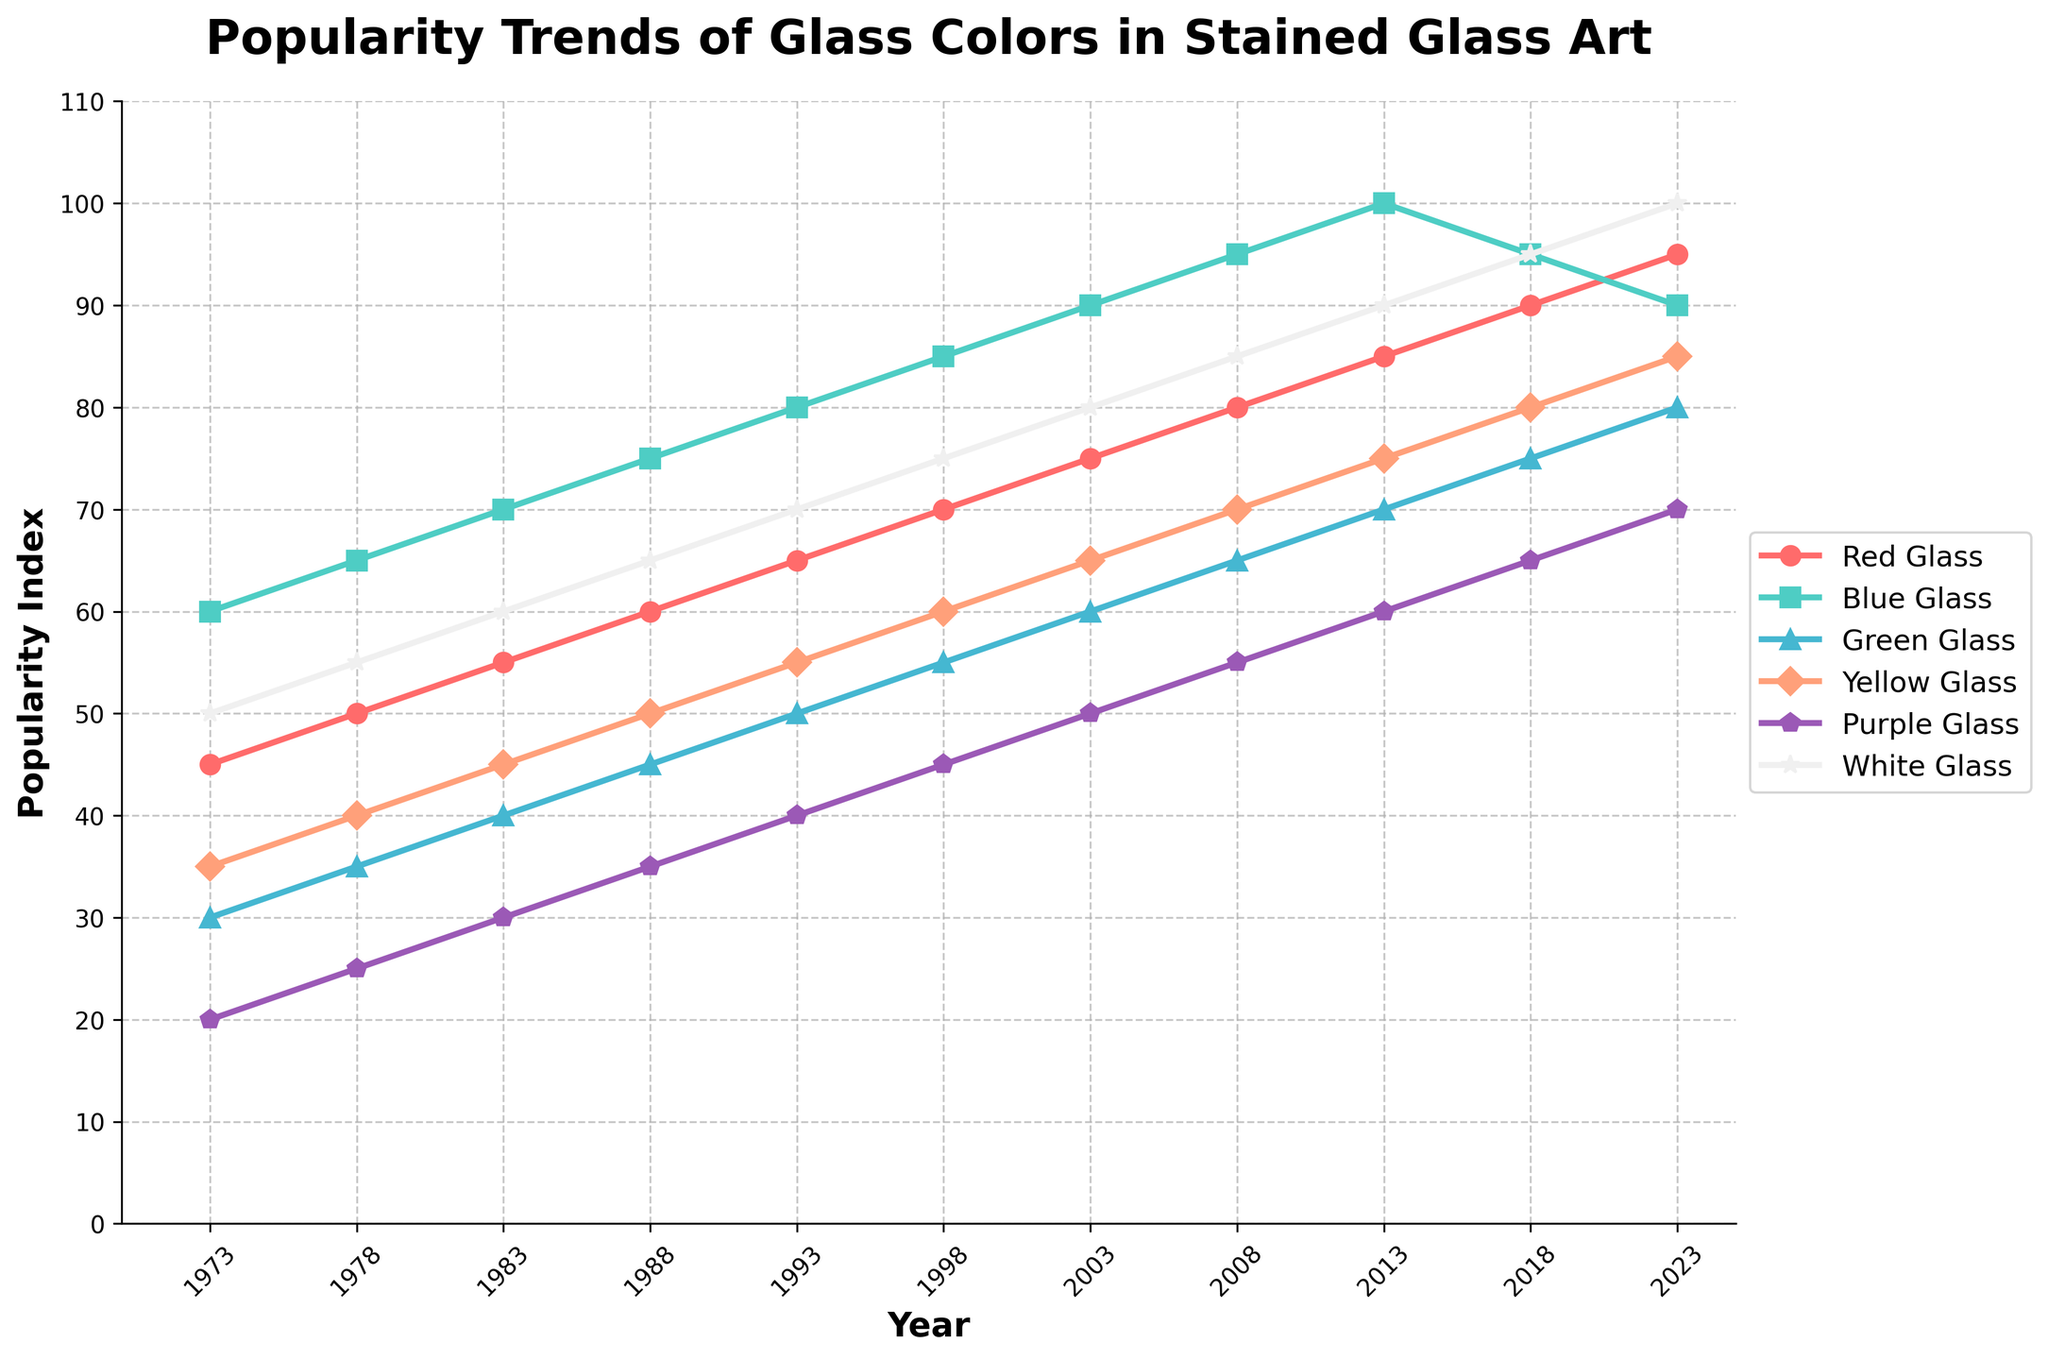What type of glass was the most popular in 2023? By checking the plot for the year 2023, we see that the highest popularity index is given to White Glass.
Answer: White Glass Which year did Blue Glass peak in popularity? Observing the data point trends, Blue Glass reached its highest value of 100 in the year 2013.
Answer: 2013 How did the popularity of Red Glass and Purple Glass compare in 2018? In 2018, the plot shows Red Glass at 90 and Purple Glass at 65, meaning Red Glass was more popular by 25 points.
Answer: Red Glass was more popular by 25 points What is the average popularity index for Green Glass over the past 50 years? Green Glass values are 30, 35, 40, 45, 50, 55, 60, 65, 70, 75, 80. Adding these gives 605, and dividing by 11 gives an average of 55.
Answer: 55 Did Blue Glass see a continuous increase in popularity from 1973 to 2023? Tracking Blue Glass through the plot, we observe a continuous increase until 2013, after which it slightly decreased by 2023.
Answer: No Which color has the least variation in popularity over time? By observing each color's trend line, White Glass shows the most consistent, steady increase compared to the more fluctuating trends of other colors.
Answer: White Glass What is the difference in popularity index between Red Glass and Blue Glass in 2003? From the plot, in 2003, Red Glass is at 75, and Blue Glass at 90. The difference is 90 - 75 = 15.
Answer: 15 What can you infer about the popularity trend of Yellow Glass? Yellow Glass shows a steady increase over time, indicating a growing preference or steady demand in the stained glass art community.
Answer: Steady increase How did the popularity of Green Glass change between 1988 and 1993? Between 1988 (45) and 1993 (50), Green Glass's popularity increased by 5 points.
Answer: Increased by 5 points Which years witnessed a decrease in popularity index for Blue Glass? Based on the plot, Blue Glass experienced a decrease in popularity index from 2013 to 2023.
Answer: 2013 to 2023 